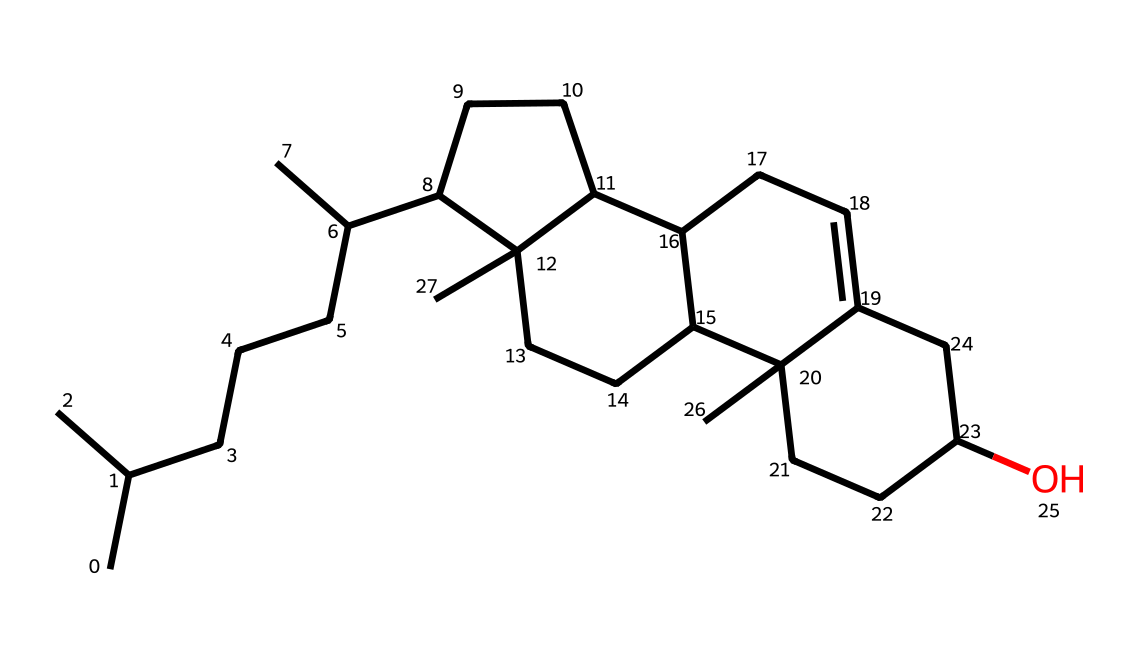How many carbon atoms are present in cholesterol? By examining the provided SMILES representation, we identify the number of carbon atoms (C) directly by counting the 'C' characters, which represents carbon. In this SMILES, there are 27 'C' characters.
Answer: 27 What is the total number of hydrogen atoms in cholesterol? To find the number of hydrogen atoms in the structure, we need to consider the valencies of carbon atoms. Each carbon generally forms four bonds. By analyzing the structure, we can infer that cholesterol has 46 hydrogen atoms to satisfy the bonding requirements of the carbon skeleton.
Answer: 46 What type of hydrocarbon structure does cholesterol represent? Cholesterol possesses a steroid structure which includes multiple fused rings, characteristic of steroids. The structure can be visually derived from the number of interconnected rings shown in the SMILES and the functional groups associated with it.
Answer: steroid What functional group is present in cholesterol? The presence of an 'OH' in the SMILES indicates the presence of a hydroxyl group, which is a functional group in cholesterol that contributes to its properties as a sterol.
Answer: hydroxyl How many rings are present in the cholesterol structure? Cholesterol has a tetracyclic structure, which means it contains four fused rings. By analyzing the SMILES notation, we can see the notation indicates connections between multiple carbon atoms that form these rings.
Answer: four What is the significance of the hydroxyl group in the structure of cholesterol? The hydroxyl group contributes to the amphipathic nature of cholesterol, allowing it to play a crucial role in cell membrane fluidity and permeability. It is also vital for its interaction with other biomolecules within the membrane context.
Answer: amphipathic nature 